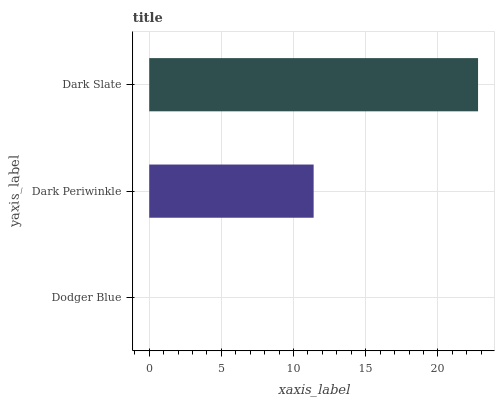Is Dodger Blue the minimum?
Answer yes or no. Yes. Is Dark Slate the maximum?
Answer yes or no. Yes. Is Dark Periwinkle the minimum?
Answer yes or no. No. Is Dark Periwinkle the maximum?
Answer yes or no. No. Is Dark Periwinkle greater than Dodger Blue?
Answer yes or no. Yes. Is Dodger Blue less than Dark Periwinkle?
Answer yes or no. Yes. Is Dodger Blue greater than Dark Periwinkle?
Answer yes or no. No. Is Dark Periwinkle less than Dodger Blue?
Answer yes or no. No. Is Dark Periwinkle the high median?
Answer yes or no. Yes. Is Dark Periwinkle the low median?
Answer yes or no. Yes. Is Dodger Blue the high median?
Answer yes or no. No. Is Dodger Blue the low median?
Answer yes or no. No. 